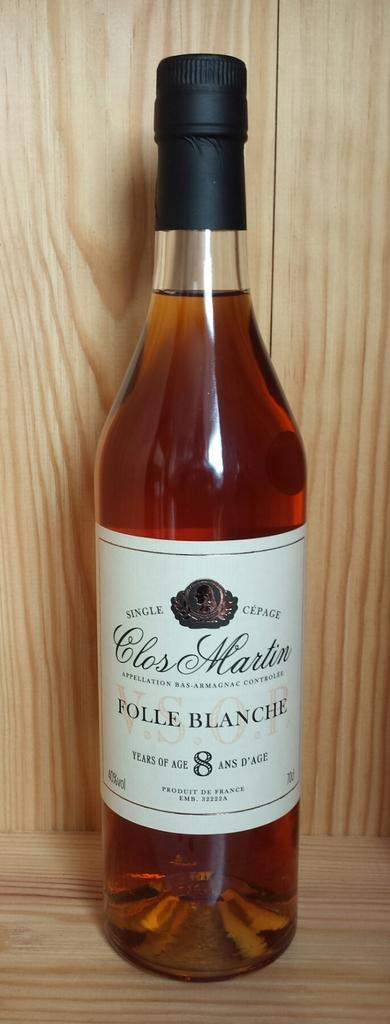Provide a one-sentence caption for the provided image. The cognac is aged 8 years and is a product of France. 